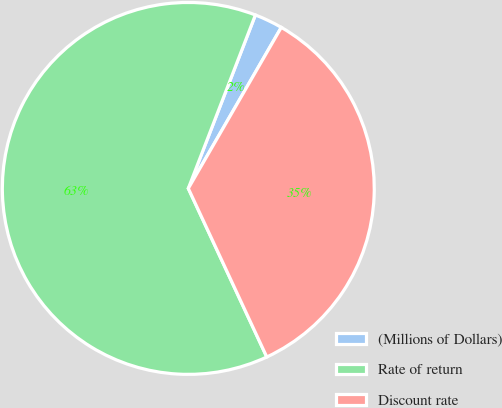Convert chart to OTSL. <chart><loc_0><loc_0><loc_500><loc_500><pie_chart><fcel>(Millions of Dollars)<fcel>Rate of return<fcel>Discount rate<nl><fcel>2.46%<fcel>62.81%<fcel>34.73%<nl></chart> 